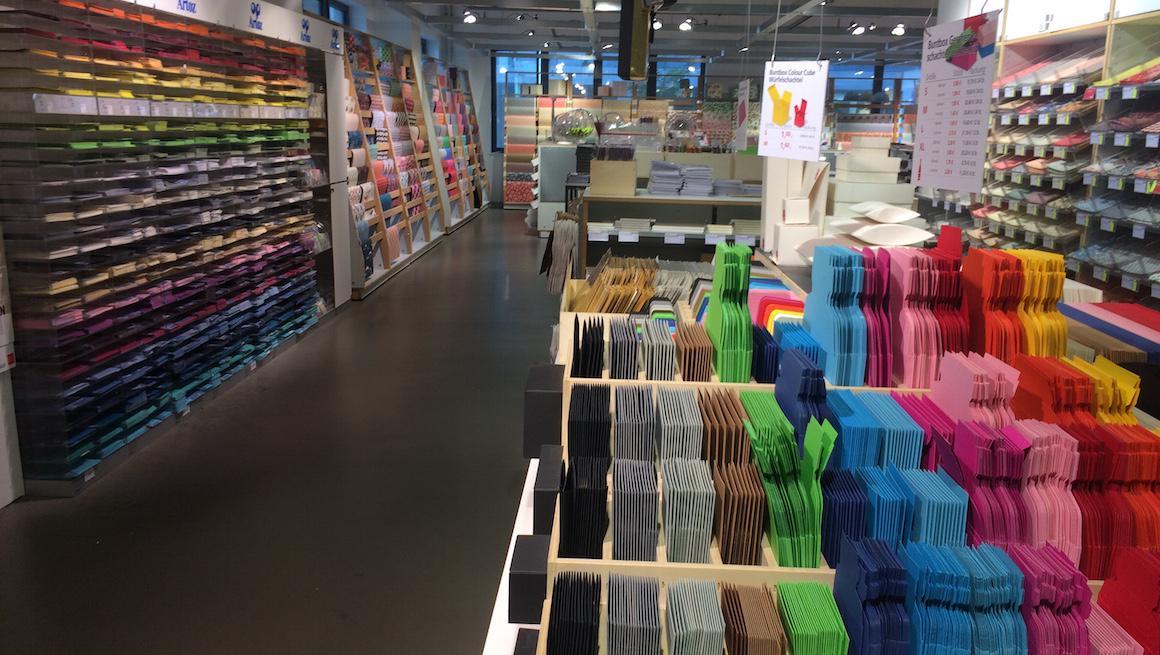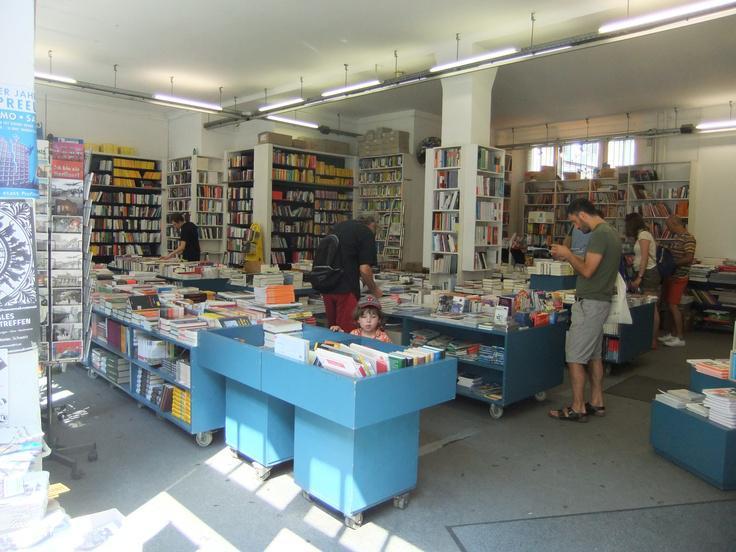The first image is the image on the left, the second image is the image on the right. Analyze the images presented: Is the assertion "There are multiple people in a shop in the right image." valid? Answer yes or no. Yes. The first image is the image on the left, the second image is the image on the right. Examine the images to the left and right. Is the description "There are three people in a bookstore." accurate? Answer yes or no. No. 